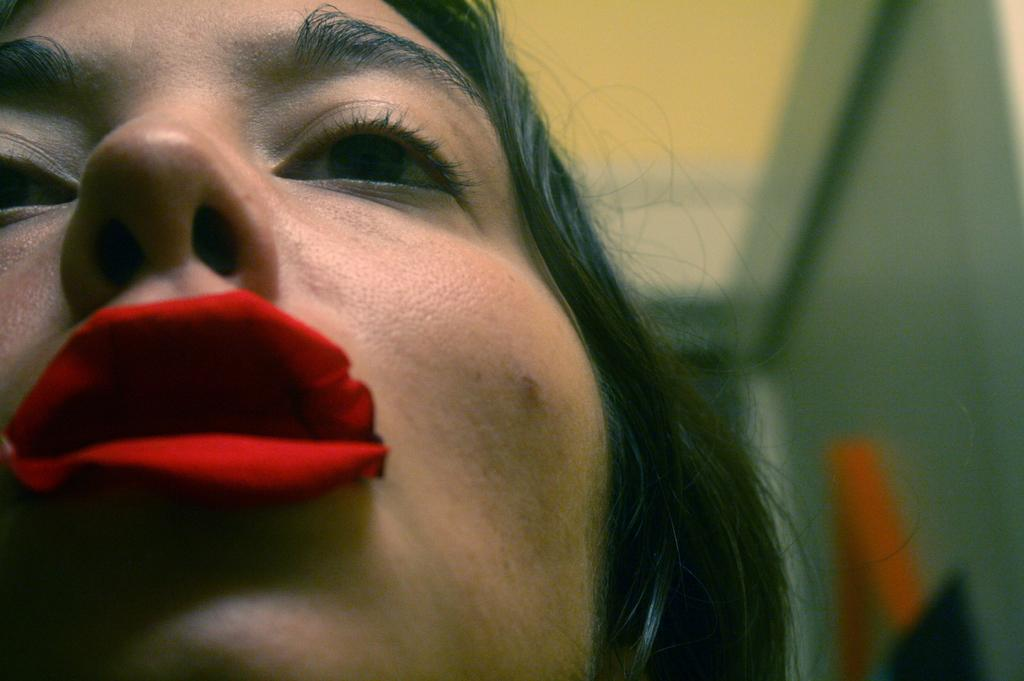Who is the main subject in the foreground of the image? There is a woman in the foreground of the image. Where is the woman positioned in the image? The woman is on the left side of the image. What is on the woman's lips in the image? There is a rose petal on the woman's lips. How would you describe the background of the image? The background of the image is blurred. What type of grain is being harvested in the background of the image? There is no grain or harvesting activity present in the image; the background is blurred. 